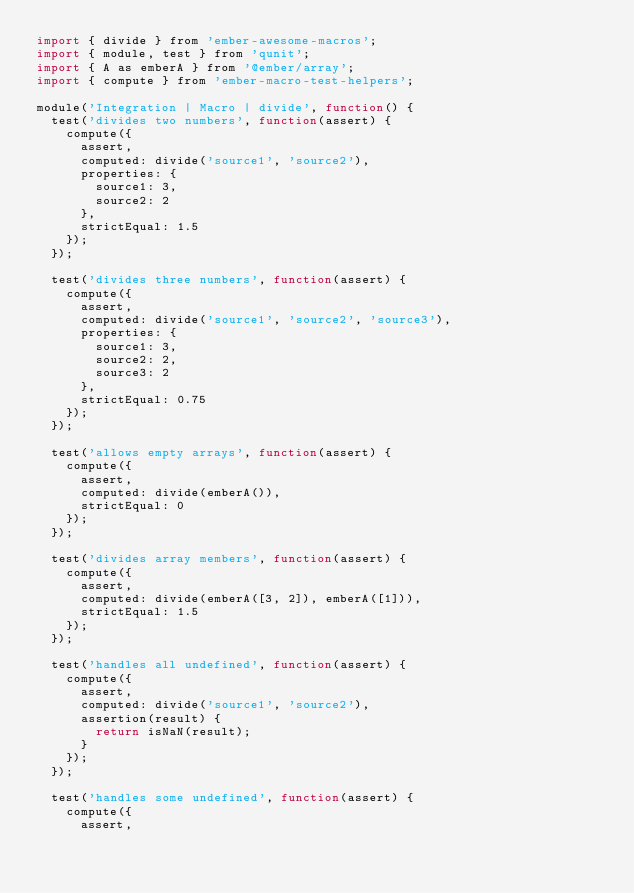<code> <loc_0><loc_0><loc_500><loc_500><_JavaScript_>import { divide } from 'ember-awesome-macros';
import { module, test } from 'qunit';
import { A as emberA } from '@ember/array';
import { compute } from 'ember-macro-test-helpers';

module('Integration | Macro | divide', function() {
  test('divides two numbers', function(assert) {
    compute({
      assert,
      computed: divide('source1', 'source2'),
      properties: {
        source1: 3,
        source2: 2
      },
      strictEqual: 1.5
    });
  });

  test('divides three numbers', function(assert) {
    compute({
      assert,
      computed: divide('source1', 'source2', 'source3'),
      properties: {
        source1: 3,
        source2: 2,
        source3: 2
      },
      strictEqual: 0.75
    });
  });

  test('allows empty arrays', function(assert) {
    compute({
      assert,
      computed: divide(emberA()),
      strictEqual: 0
    });
  });

  test('divides array members', function(assert) {
    compute({
      assert,
      computed: divide(emberA([3, 2]), emberA([1])),
      strictEqual: 1.5
    });
  });

  test('handles all undefined', function(assert) {
    compute({
      assert,
      computed: divide('source1', 'source2'),
      assertion(result) {
        return isNaN(result);
      }
    });
  });

  test('handles some undefined', function(assert) {
    compute({
      assert,</code> 